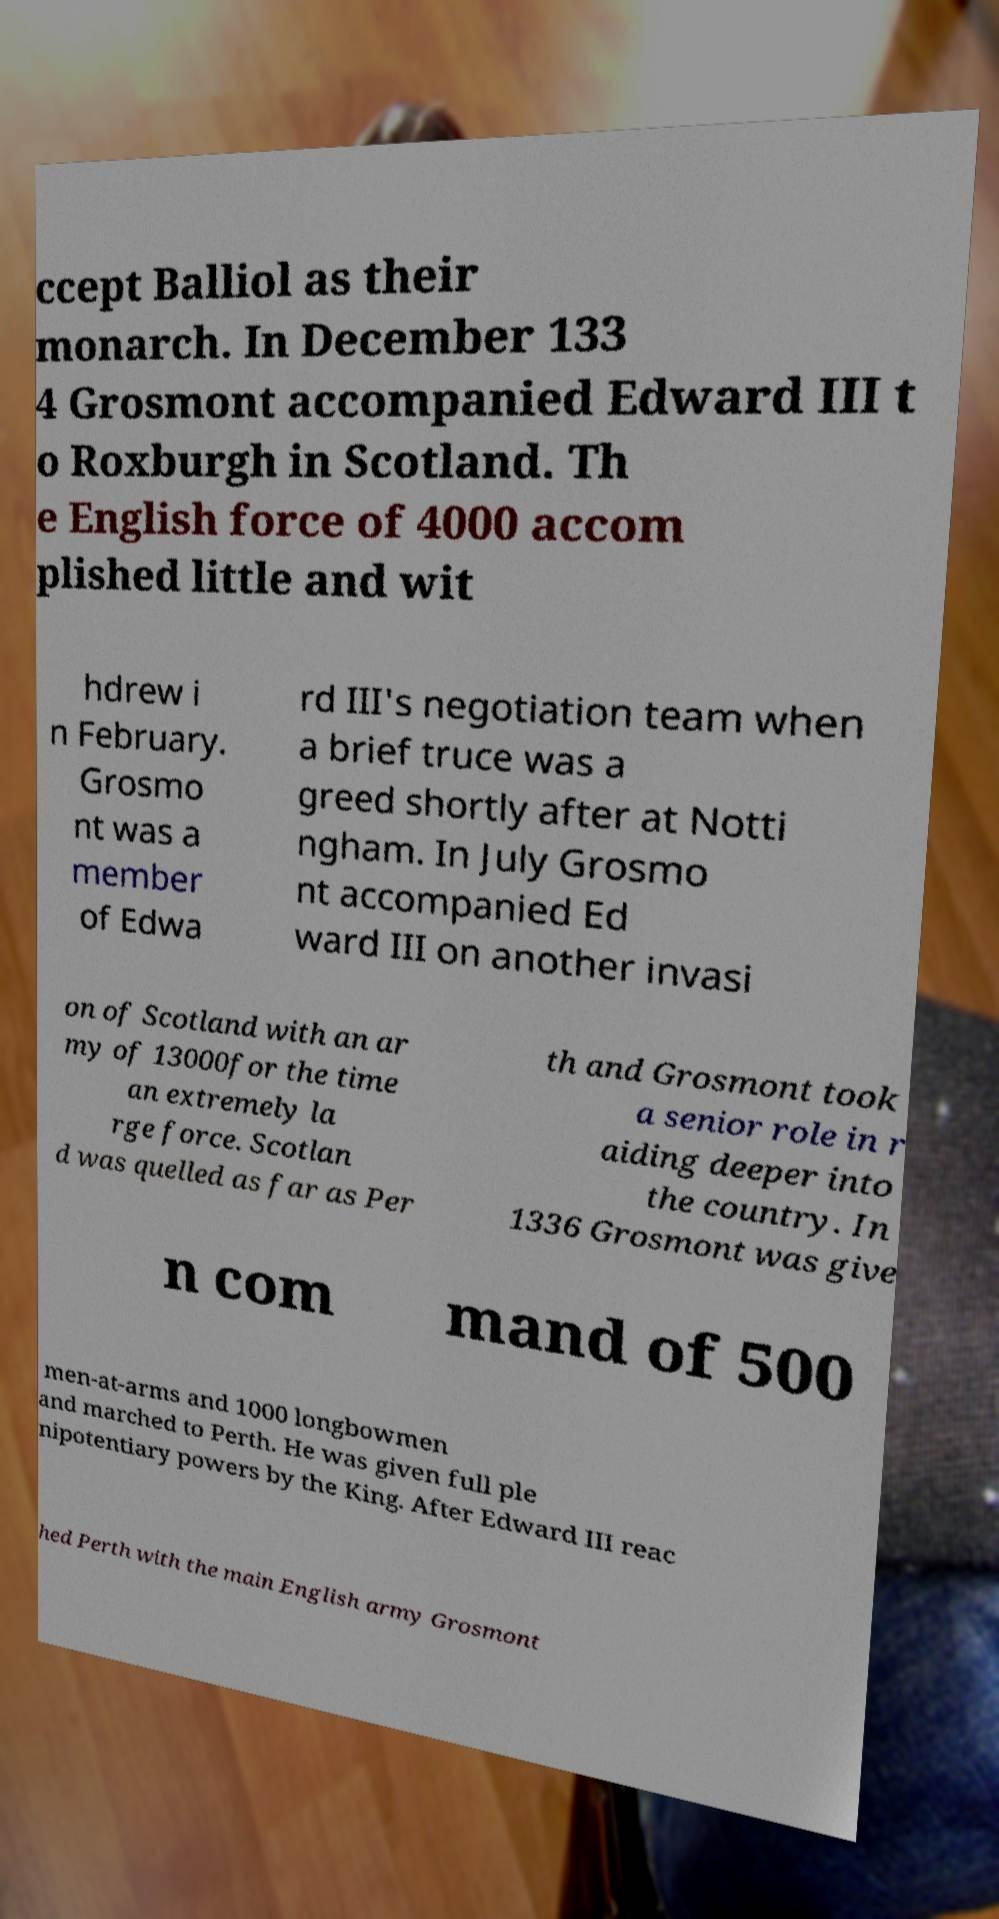Could you assist in decoding the text presented in this image and type it out clearly? ccept Balliol as their monarch. In December 133 4 Grosmont accompanied Edward III t o Roxburgh in Scotland. Th e English force of 4000 accom plished little and wit hdrew i n February. Grosmo nt was a member of Edwa rd III's negotiation team when a brief truce was a greed shortly after at Notti ngham. In July Grosmo nt accompanied Ed ward III on another invasi on of Scotland with an ar my of 13000for the time an extremely la rge force. Scotlan d was quelled as far as Per th and Grosmont took a senior role in r aiding deeper into the country. In 1336 Grosmont was give n com mand of 500 men-at-arms and 1000 longbowmen and marched to Perth. He was given full ple nipotentiary powers by the King. After Edward III reac hed Perth with the main English army Grosmont 